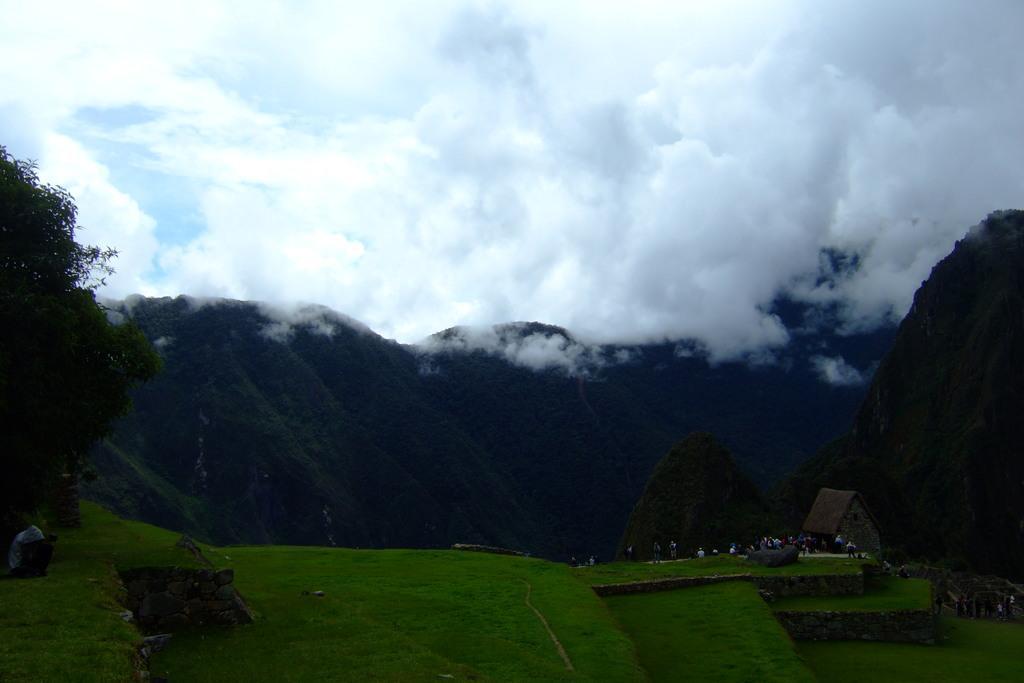Can you describe this image briefly? In this picture we can see a few people on the path. Some grass is visible on the ground. There is a tree on the left side. We can see rocks and a house on the right side. Sky is cloudy. 